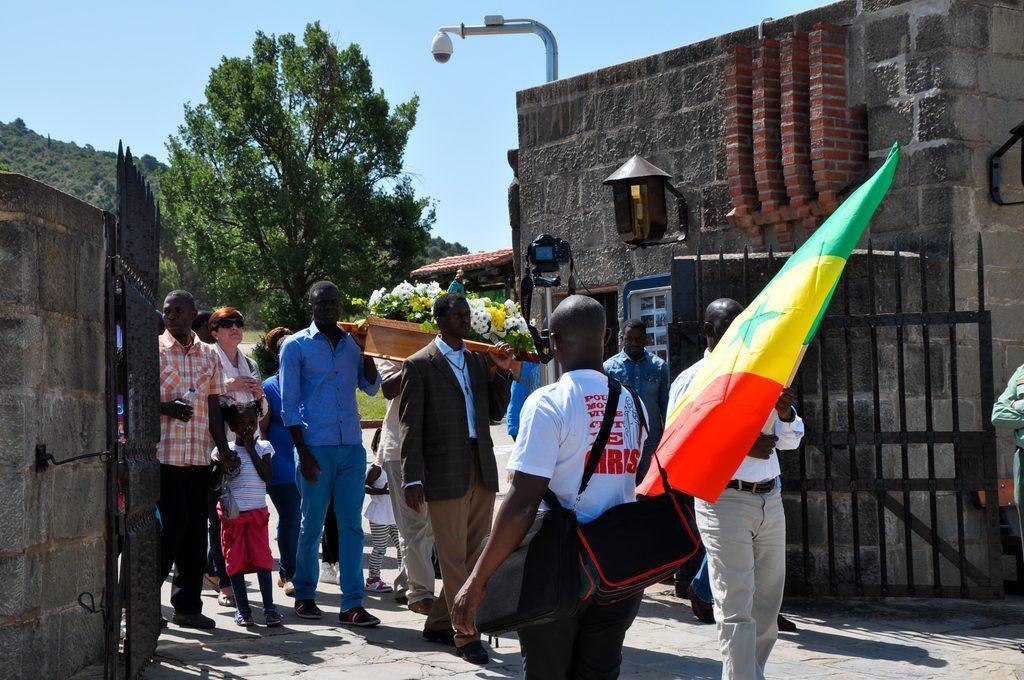Please provide a concise description of this image. In this image we can see many people. One person is wearing bags. Another person is holding a flag. There are gates. Also there are walls. And there is a camera on a pole. And there are flowers in basket. Few people are holding the basket. In the background there are trees and there is sky. 